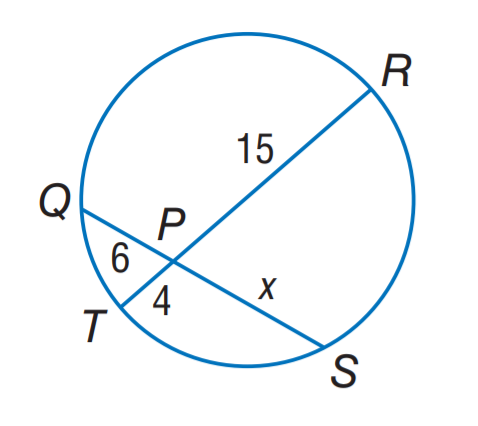Answer the mathemtical geometry problem and directly provide the correct option letter.
Question: Find x.
Choices: A: 4 B: 6 C: 10 D: 15 C 